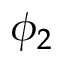<formula> <loc_0><loc_0><loc_500><loc_500>\phi _ { 2 }</formula> 